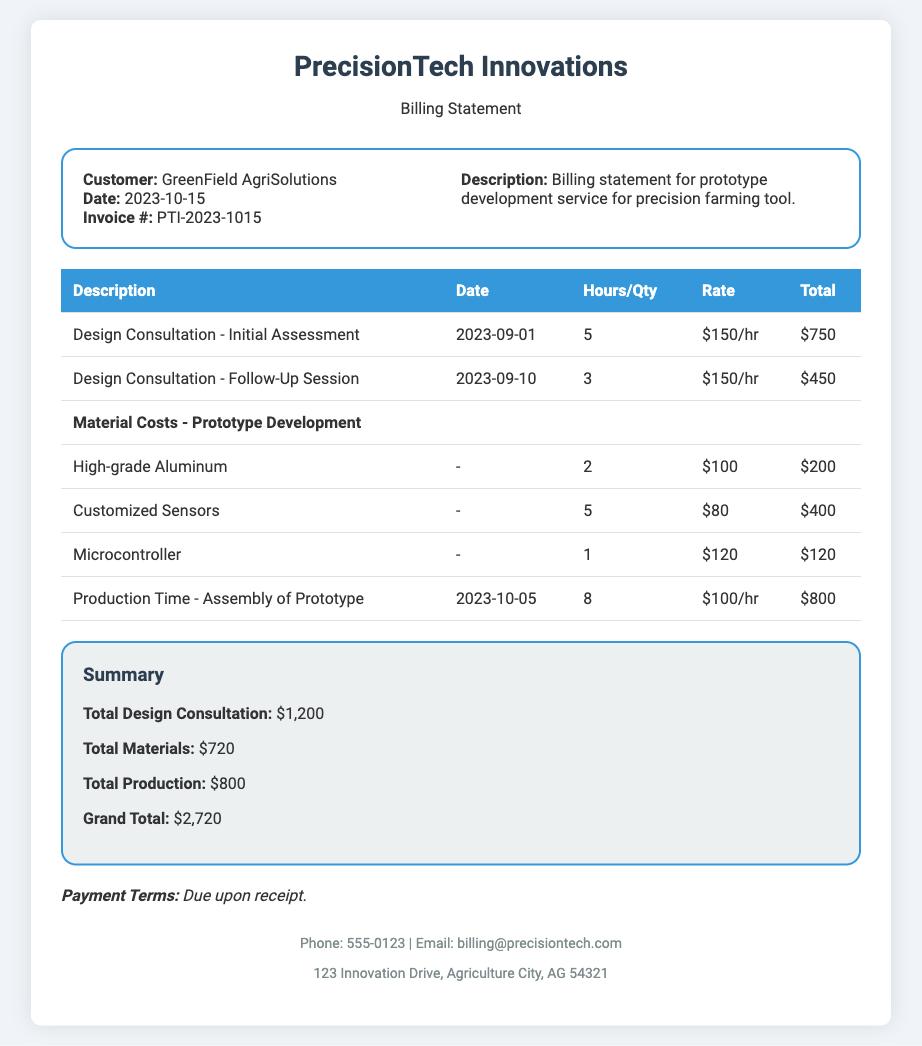what is the invoice number? The invoice number is specified in the document under the invoice details section, which is PTI-2023-1015.
Answer: PTI-2023-1015 who is the customer? The customer's name is provided in the invoice details section, which is GreenField AgriSolutions.
Answer: GreenField AgriSolutions what is the total for design consultations? The total for design consultations is provided in the summary section, which is $1,200.
Answer: $1,200 how many hours were billed for the assembly of the prototype? The hours billed for the assembly of the prototype are listed in the production time row, which is 8 hours.
Answer: 8 what is the grand total amount due? The grand total amount due is specified in the summary section of the document, which is $2,720.
Answer: $2,720 when was the design consultation follow-up session? The date of the design consultation follow-up session is provided in the table, which is 2023-09-10.
Answer: 2023-09-10 how much was charged for high-grade aluminum? The charge for high-grade aluminum is provided in the materials section of the table, which is $200.
Answer: $200 what are the payment terms stated in the document? The payment terms are mentioned in the payment terms section, which states that payment is due upon receipt.
Answer: Due upon receipt 